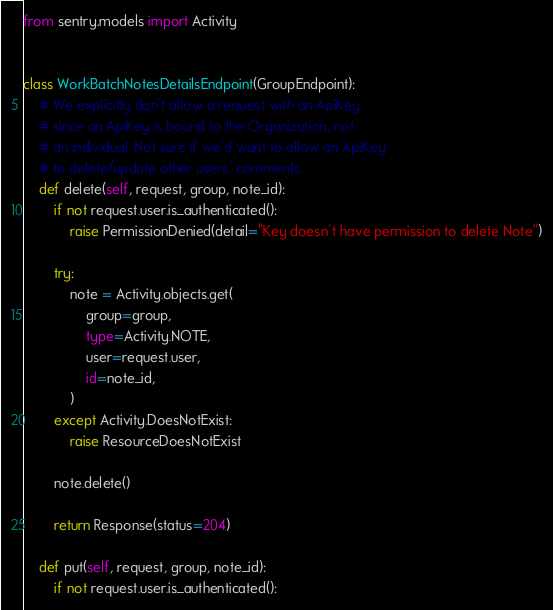Convert code to text. <code><loc_0><loc_0><loc_500><loc_500><_Python_>from sentry.models import Activity


class WorkBatchNotesDetailsEndpoint(GroupEndpoint):
    # We explicitly don't allow a request with an ApiKey
    # since an ApiKey is bound to the Organization, not
    # an individual. Not sure if we'd want to allow an ApiKey
    # to delete/update other users' comments
    def delete(self, request, group, note_id):
        if not request.user.is_authenticated():
            raise PermissionDenied(detail="Key doesn't have permission to delete Note")

        try:
            note = Activity.objects.get(
                group=group,
                type=Activity.NOTE,
                user=request.user,
                id=note_id,
            )
        except Activity.DoesNotExist:
            raise ResourceDoesNotExist

        note.delete()

        return Response(status=204)

    def put(self, request, group, note_id):
        if not request.user.is_authenticated():</code> 